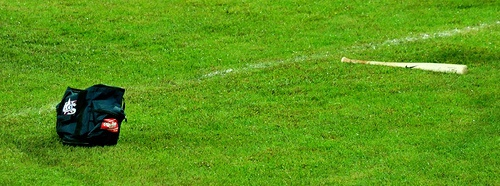Describe the objects in this image and their specific colors. I can see backpack in olive, black, teal, darkblue, and green tones, handbag in olive, black, teal, darkblue, and white tones, and baseball bat in olive, lightyellow, and khaki tones in this image. 